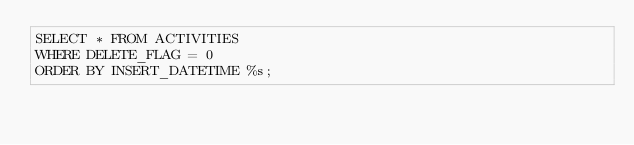<code> <loc_0><loc_0><loc_500><loc_500><_SQL_>SELECT * FROM ACTIVITIES
WHERE DELETE_FLAG = 0
ORDER BY INSERT_DATETIME %s;
</code> 